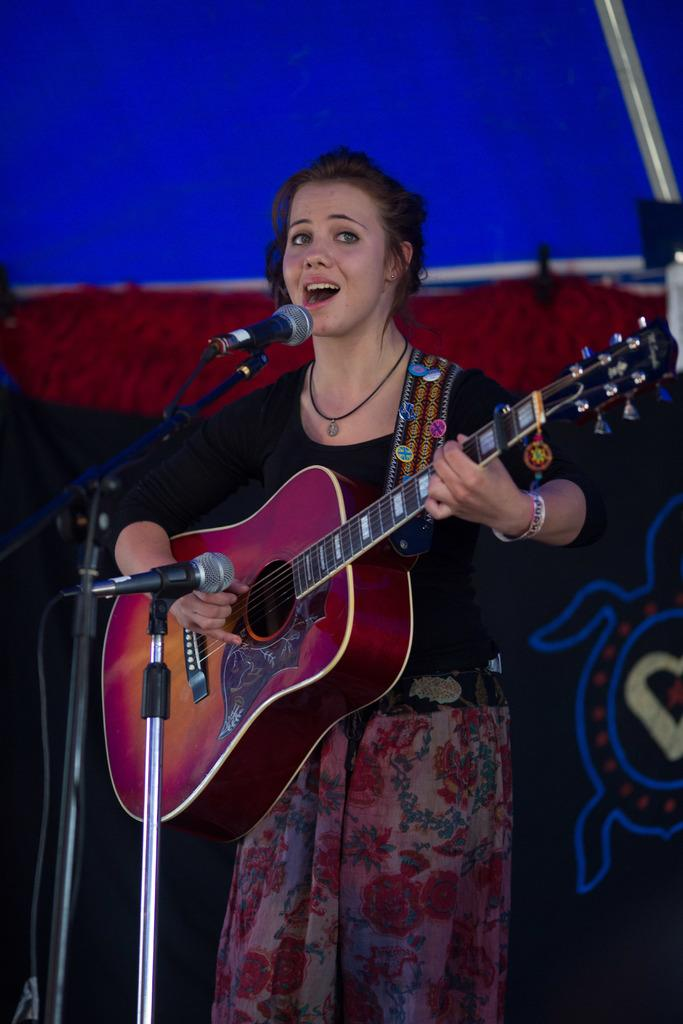Who is the main subject in the image? There is a woman in the image. What is the woman doing in the image? The woman is playing a guitar and singing. What is the woman wearing in the image? The woman is wearing a black t-shirt. What is the woman standing in front of in the image? The woman is in front of a microphone. Can you hear the son playing the piano during the thunderstorm in the image? There is no son or piano playing in the image, nor is there any mention of a thunderstorm. 